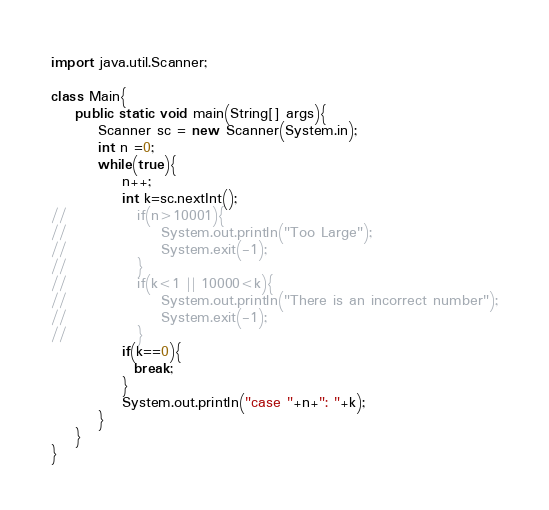<code> <loc_0><loc_0><loc_500><loc_500><_Java_>import java.util.Scanner;

class Main{
    public static void main(String[] args){
        Scanner sc = new Scanner(System.in);
        int n =0;
        while(true){
            n++;
            int k=sc.nextInt();
//            if(n>10001){
//                System.out.println("Too Large");
//                System.exit(-1);
//            }
//            if(k<1 || 10000<k){
//                System.out.println("There is an incorrect number");
//                System.exit(-1);
//            }
            if(k==0){
              break;
            }
            System.out.println("case "+n+": "+k);
        }
    }
}</code> 